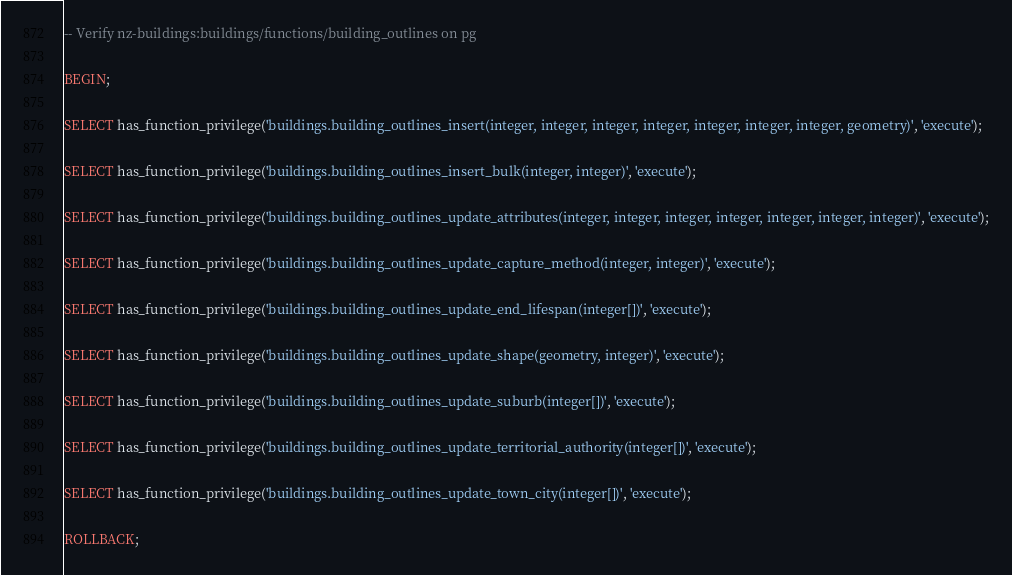<code> <loc_0><loc_0><loc_500><loc_500><_SQL_>-- Verify nz-buildings:buildings/functions/building_outlines on pg

BEGIN;

SELECT has_function_privilege('buildings.building_outlines_insert(integer, integer, integer, integer, integer, integer, integer, geometry)', 'execute');

SELECT has_function_privilege('buildings.building_outlines_insert_bulk(integer, integer)', 'execute');

SELECT has_function_privilege('buildings.building_outlines_update_attributes(integer, integer, integer, integer, integer, integer, integer)', 'execute');

SELECT has_function_privilege('buildings.building_outlines_update_capture_method(integer, integer)', 'execute');

SELECT has_function_privilege('buildings.building_outlines_update_end_lifespan(integer[])', 'execute');

SELECT has_function_privilege('buildings.building_outlines_update_shape(geometry, integer)', 'execute');

SELECT has_function_privilege('buildings.building_outlines_update_suburb(integer[])', 'execute');

SELECT has_function_privilege('buildings.building_outlines_update_territorial_authority(integer[])', 'execute');

SELECT has_function_privilege('buildings.building_outlines_update_town_city(integer[])', 'execute');

ROLLBACK;
</code> 